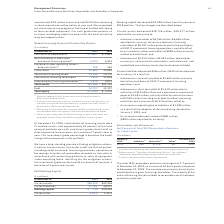According to International Business Machines's financial document, What percent of the total external portfolio was with investment-grade clients with no direct exposure to consumers? According to the financial document, 62 percent. The relevant text states: "assets were IT-related assets, and approximately 62 percent of the total external portfolio was with investment-grade clients with no direct exposure to consum..." Also, What will be the increase in the investment grade post adjusting for mitigation actions? According to the financial document, 67 percent. The relevant text states: "s, the investment-grade content would increase to 67 percent, a decrease of 3 points year to year...." Also, What was the available cash in 2019? According to the financial document, $ 1,697 (in millions). The relevant text states: "Cash and cash equivalents $ 1,697 $ 1,833..." Also, can you calculate: What is the increase / (decrease) in the cash from 2018 to 2019? Based on the calculation: 1,697 - 1,833, the result is -136 (in millions). This is based on the information: "Cash and cash equivalents $ 1,697 $ 1,833 Cash and cash equivalents $ 1,697 $ 1,833..." The key data points involved are: 1,697, 1,833. Also, can you calculate: What is the average of Equipment under operating leases— external clients? To answer this question, I need to perform calculations using the financial data. The calculation is: (238 + 444) / 2, which equals 341 (in millions). This is based on the information: "under operating leases— external clients (2) 238 444 ment under operating leases— external clients (2) 238 444..." The key data points involved are: 238, 444. Also, can you calculate: What is the percentage increase / (decrease) in Total client financing assets from 2018 to 2019?  To answer this question, I need to perform calculations using the financial data. The calculation is: 19,346 / 20,170 - 1, which equals -4.09 (percentage). This is based on the information: "Total client financing assets 19,346 20,170 Total client financing assets 19,346 20,170..." The key data points involved are: 19,346, 20,170. 